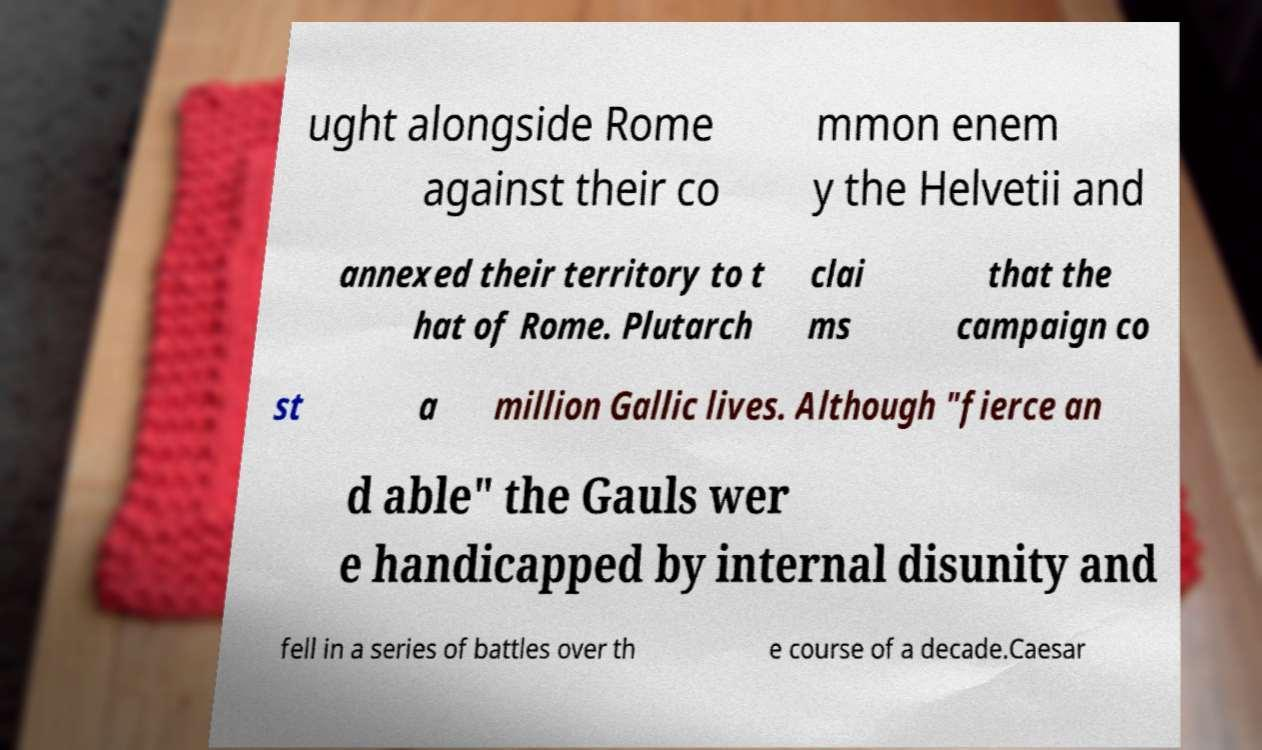Can you read and provide the text displayed in the image?This photo seems to have some interesting text. Can you extract and type it out for me? ught alongside Rome against their co mmon enem y the Helvetii and annexed their territory to t hat of Rome. Plutarch clai ms that the campaign co st a million Gallic lives. Although "fierce an d able" the Gauls wer e handicapped by internal disunity and fell in a series of battles over th e course of a decade.Caesar 